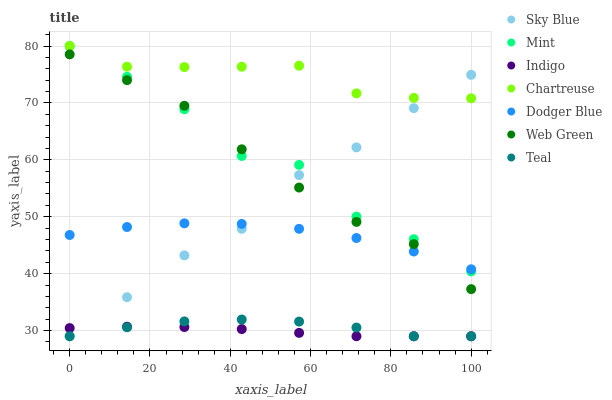Does Indigo have the minimum area under the curve?
Answer yes or no. Yes. Does Chartreuse have the maximum area under the curve?
Answer yes or no. Yes. Does Web Green have the minimum area under the curve?
Answer yes or no. No. Does Web Green have the maximum area under the curve?
Answer yes or no. No. Is Indigo the smoothest?
Answer yes or no. Yes. Is Mint the roughest?
Answer yes or no. Yes. Is Web Green the smoothest?
Answer yes or no. No. Is Web Green the roughest?
Answer yes or no. No. Does Indigo have the lowest value?
Answer yes or no. Yes. Does Web Green have the lowest value?
Answer yes or no. No. Does Mint have the highest value?
Answer yes or no. Yes. Does Web Green have the highest value?
Answer yes or no. No. Is Teal less than Chartreuse?
Answer yes or no. Yes. Is Chartreuse greater than Indigo?
Answer yes or no. Yes. Does Chartreuse intersect Sky Blue?
Answer yes or no. Yes. Is Chartreuse less than Sky Blue?
Answer yes or no. No. Is Chartreuse greater than Sky Blue?
Answer yes or no. No. Does Teal intersect Chartreuse?
Answer yes or no. No. 